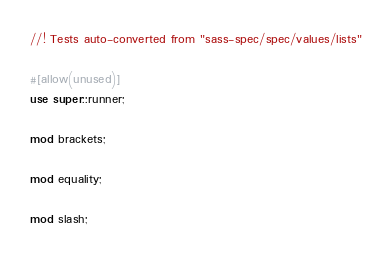Convert code to text. <code><loc_0><loc_0><loc_500><loc_500><_Rust_>//! Tests auto-converted from "sass-spec/spec/values/lists"

#[allow(unused)]
use super::runner;

mod brackets;

mod equality;

mod slash;
</code> 